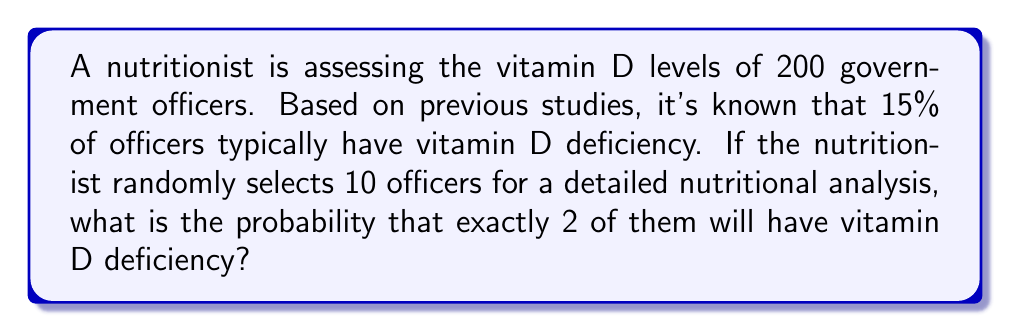Help me with this question. To solve this problem, we'll use the binomial probability distribution, as we're dealing with a fixed number of independent trials (selecting 10 officers) with two possible outcomes (deficient or not deficient) and a known probability of success (15% chance of deficiency).

The probability mass function for a binomial distribution is:

$$P(X = k) = \binom{n}{k} p^k (1-p)^{n-k}$$

Where:
$n$ = number of trials (10 officers)
$k$ = number of successes (2 officers with deficiency)
$p$ = probability of success (15% or 0.15)

Step 1: Calculate the binomial coefficient
$$\binom{10}{2} = \frac{10!}{2!(10-2)!} = \frac{10!}{2!8!} = 45$$

Step 2: Calculate $p^k$
$$0.15^2 = 0.0225$$

Step 3: Calculate $(1-p)^{n-k}$
$$(1-0.15)^{10-2} = 0.85^8 = 0.2725$$

Step 4: Multiply all components
$$45 \times 0.0225 \times 0.2725 = 0.2767$$

Therefore, the probability of exactly 2 out of 10 randomly selected officers having vitamin D deficiency is approximately 0.2767 or 27.67%.
Answer: 0.2767 